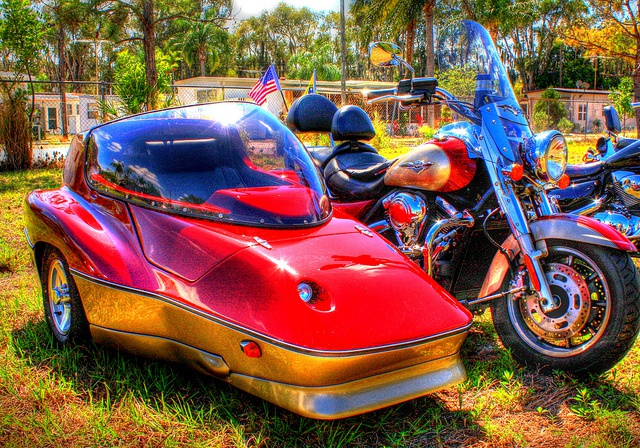Describe the objects in this image and their specific colors. I can see car in lightgray, red, black, and maroon tones, motorcycle in lightgray, black, navy, maroon, and lightblue tones, and motorcycle in lightgray, black, navy, darkblue, and lightblue tones in this image. 